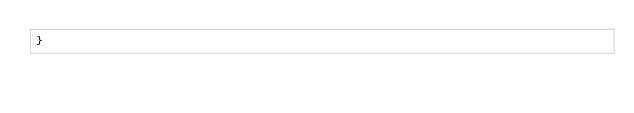Convert code to text. <code><loc_0><loc_0><loc_500><loc_500><_JavaScript_>}
</code> 